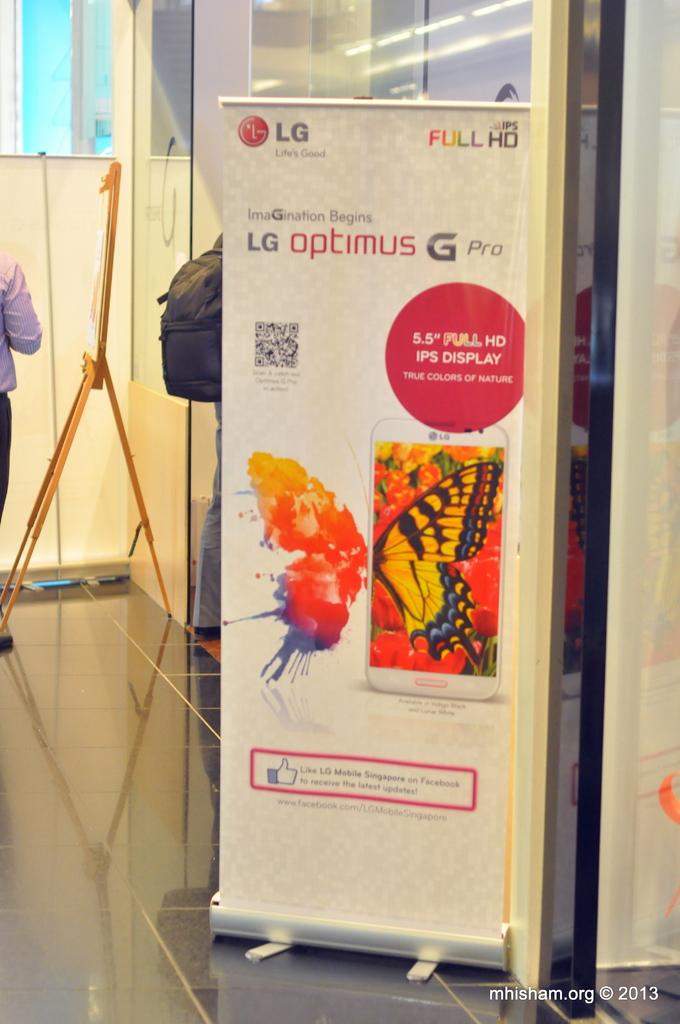What brand is the phone that is advertised?
Offer a terse response. Lg. 